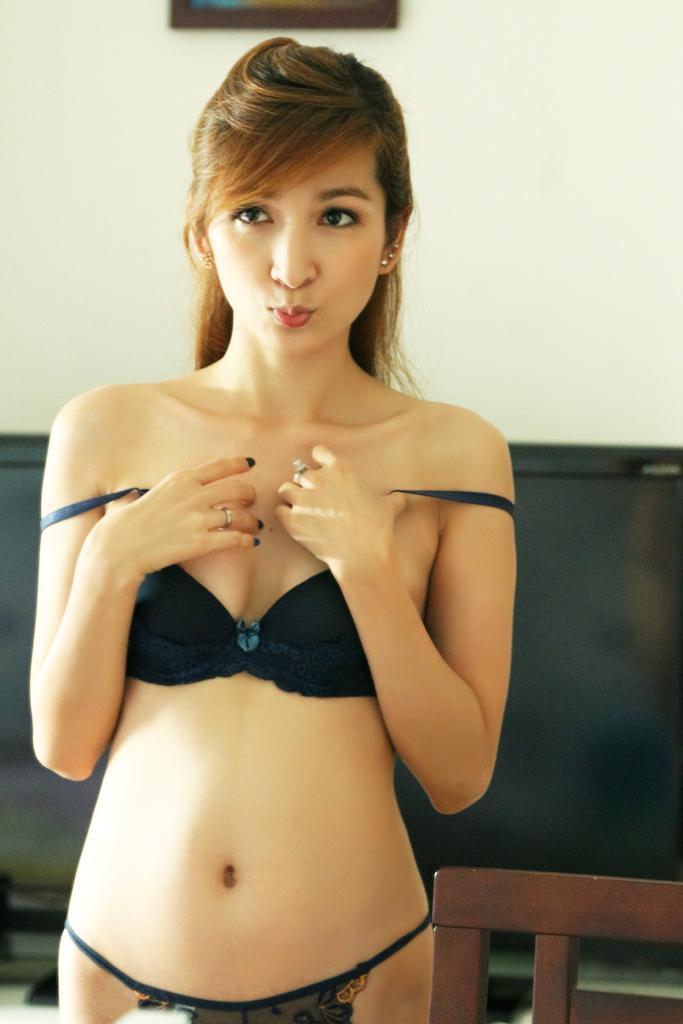Could you give a brief overview of what you see in this image? This is the woman standing. She wore a bikini dress. This looks like a chair. In the background, this is the wall. 